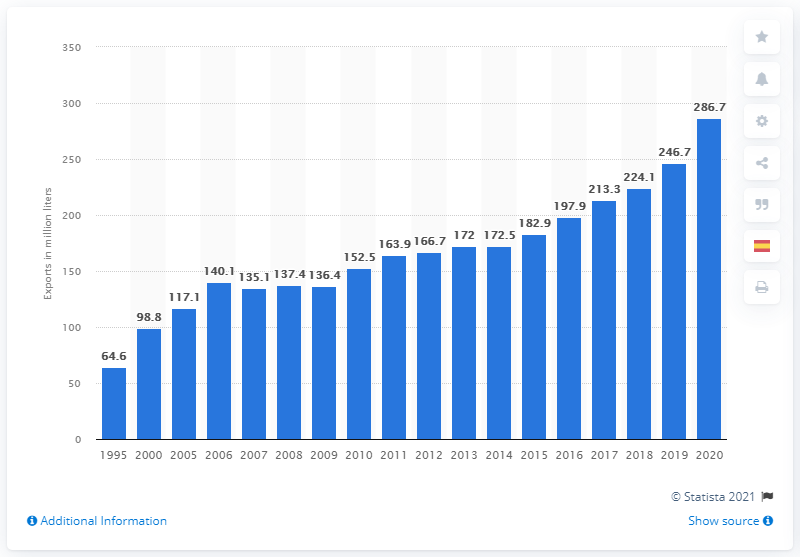Highlight a few significant elements in this photo. In 2020, Mexico exported a volume of 286.7 Million liters of tequila, an increase from the previous year. 